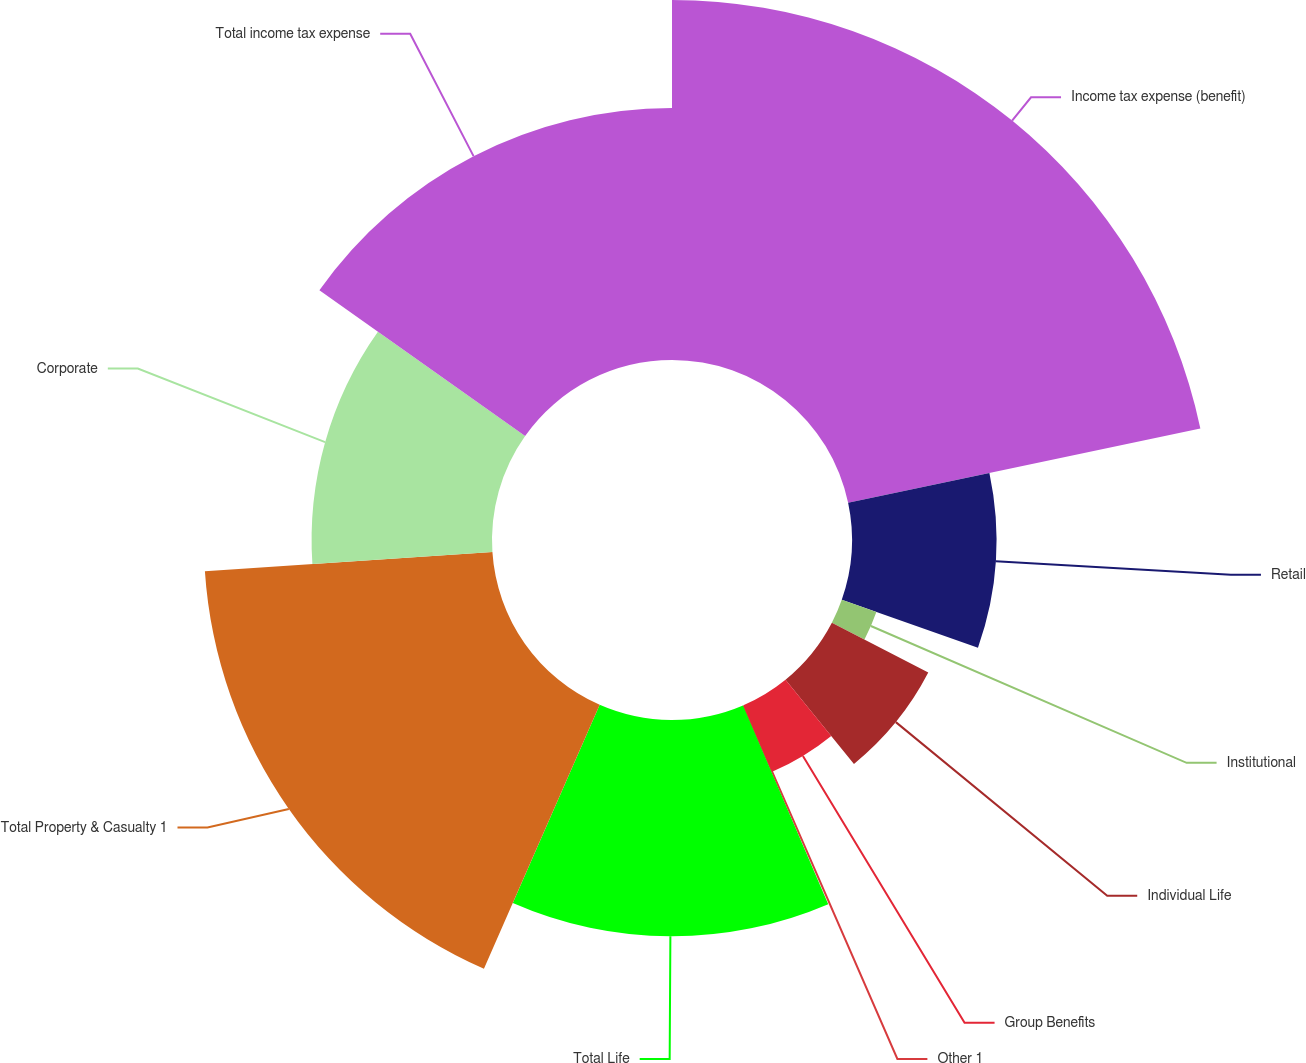Convert chart to OTSL. <chart><loc_0><loc_0><loc_500><loc_500><pie_chart><fcel>Income tax expense (benefit)<fcel>Retail<fcel>Institutional<fcel>Individual Life<fcel>Group Benefits<fcel>Other 1<fcel>Total Life<fcel>Total Property & Casualty 1<fcel>Corporate<fcel>Total income tax expense<nl><fcel>21.69%<fcel>8.7%<fcel>2.21%<fcel>6.54%<fcel>4.37%<fcel>0.04%<fcel>13.03%<fcel>17.36%<fcel>10.87%<fcel>15.19%<nl></chart> 